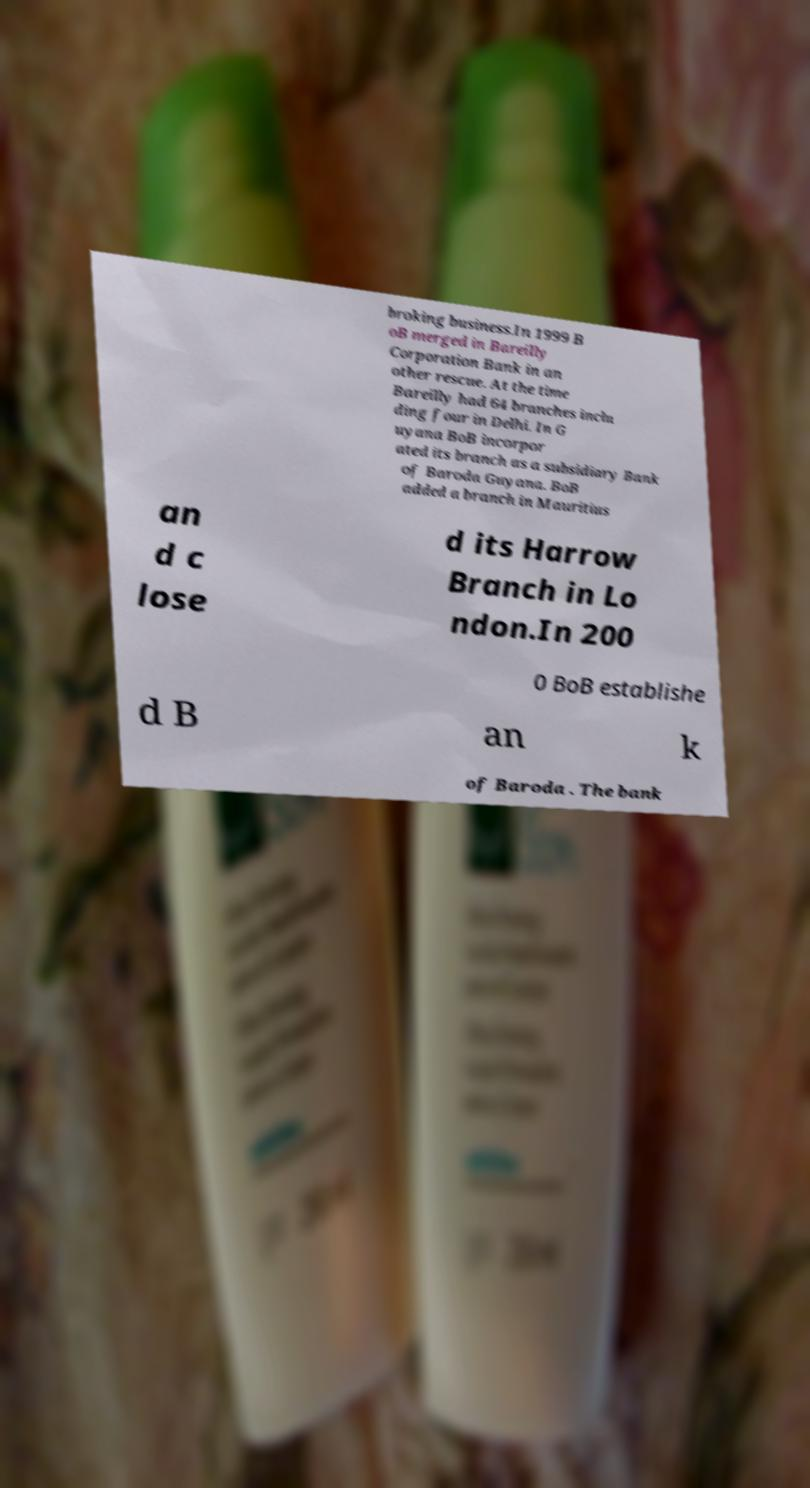For documentation purposes, I need the text within this image transcribed. Could you provide that? broking business.In 1999 B oB merged in Bareilly Corporation Bank in an other rescue. At the time Bareilly had 64 branches inclu ding four in Delhi. In G uyana BoB incorpor ated its branch as a subsidiary Bank of Baroda Guyana. BoB added a branch in Mauritius an d c lose d its Harrow Branch in Lo ndon.In 200 0 BoB establishe d B an k of Baroda . The bank 